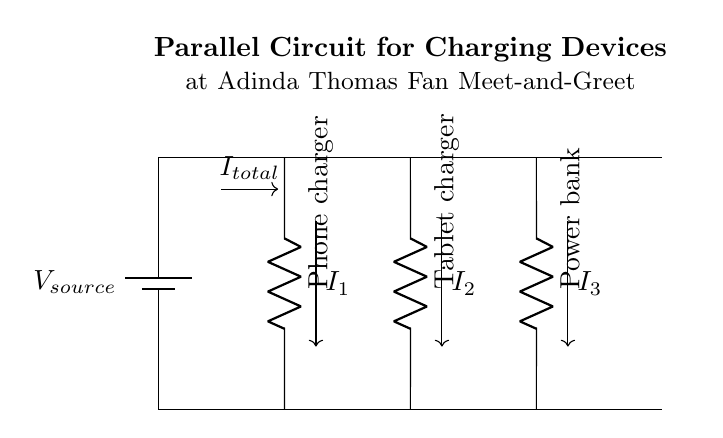What is the total current in the circuit? The total current in a parallel circuit is represented by \( I_{total} \). In this circuit, it is noted by the arrow indicating the overall current flowing to the branches.
Answer: total current Which devices are connected to the circuit? The circuit diagram shows three devices connected: a phone charger, a tablet charger, and a power bank. Each device is a resistor connected in parallel.
Answer: phone charger, tablet charger, power bank What type of circuit is shown in the diagram? The circuit type is specified as a parallel circuit. This is evident because multiple branches are connected directly across the same two points of the circuit, allowing for independent operation.
Answer: parallel How many branch connectors are there? The diagram displays three branch connectors corresponding to the three devices. Each charger is connected to its own path in the circuit.
Answer: three What is the main voltage source denoted in the circuit? The voltage source is labeled as \( V_{source} \). This indicates that it provides the necessary voltage across all devices connected in parallel.
Answer: V source If the total current is 12 Amperes, how much current flows through each device? In a parallel circuit, the total current splits among the branches. Assuming equal resistance in each device, the current would divide equally, resulting in 4 Amperes through each charger.
Answer: 4 Amperes 